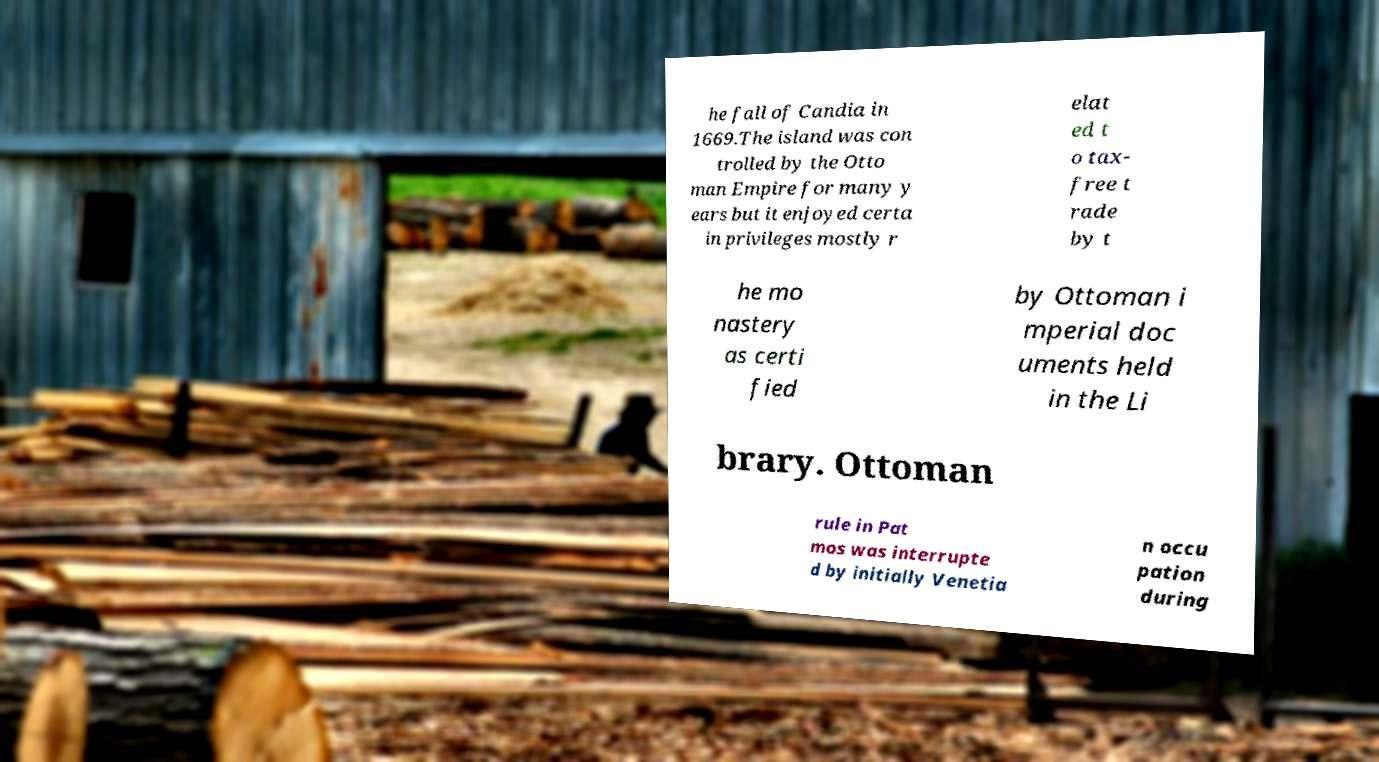Can you read and provide the text displayed in the image?This photo seems to have some interesting text. Can you extract and type it out for me? he fall of Candia in 1669.The island was con trolled by the Otto man Empire for many y ears but it enjoyed certa in privileges mostly r elat ed t o tax- free t rade by t he mo nastery as certi fied by Ottoman i mperial doc uments held in the Li brary. Ottoman rule in Pat mos was interrupte d by initially Venetia n occu pation during 